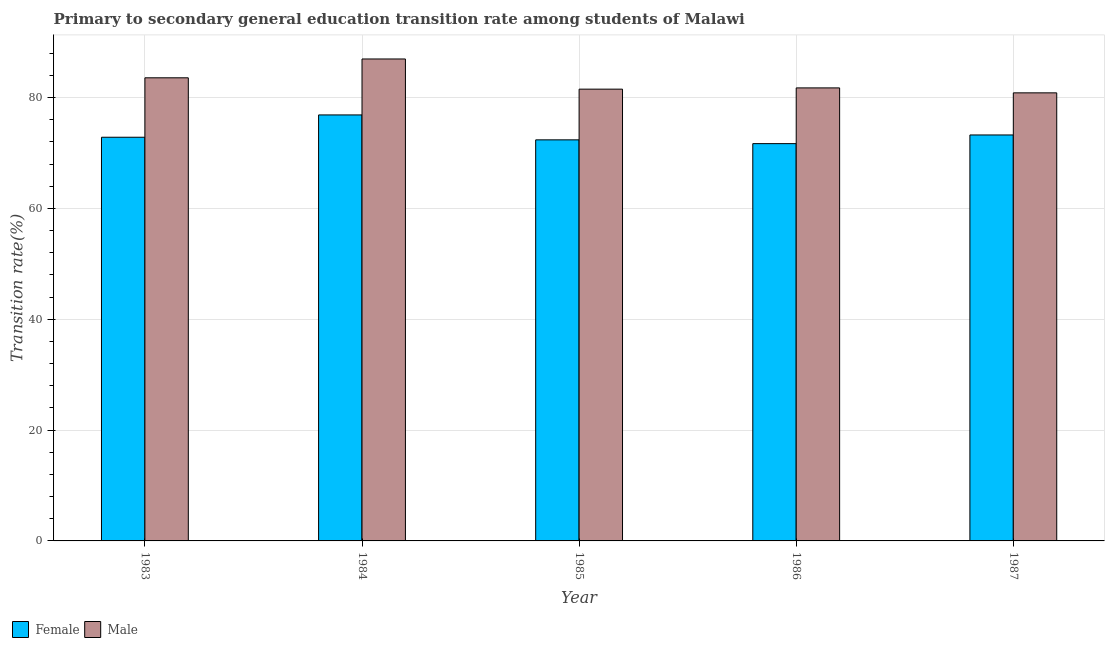How many groups of bars are there?
Offer a terse response. 5. How many bars are there on the 1st tick from the left?
Make the answer very short. 2. How many bars are there on the 1st tick from the right?
Your answer should be compact. 2. What is the transition rate among male students in 1986?
Ensure brevity in your answer.  81.76. Across all years, what is the maximum transition rate among female students?
Offer a terse response. 76.89. Across all years, what is the minimum transition rate among male students?
Provide a succinct answer. 80.87. In which year was the transition rate among male students maximum?
Your answer should be compact. 1984. In which year was the transition rate among female students minimum?
Keep it short and to the point. 1986. What is the total transition rate among male students in the graph?
Your answer should be compact. 414.74. What is the difference between the transition rate among male students in 1985 and that in 1987?
Your answer should be compact. 0.67. What is the difference between the transition rate among female students in 1986 and the transition rate among male students in 1983?
Provide a short and direct response. -1.15. What is the average transition rate among male students per year?
Offer a very short reply. 82.95. In the year 1986, what is the difference between the transition rate among male students and transition rate among female students?
Keep it short and to the point. 0. In how many years, is the transition rate among male students greater than 72 %?
Give a very brief answer. 5. What is the ratio of the transition rate among male students in 1985 to that in 1987?
Your answer should be very brief. 1.01. Is the difference between the transition rate among female students in 1986 and 1987 greater than the difference between the transition rate among male students in 1986 and 1987?
Your answer should be very brief. No. What is the difference between the highest and the second highest transition rate among female students?
Make the answer very short. 3.62. What is the difference between the highest and the lowest transition rate among male students?
Offer a terse response. 6.11. What does the 1st bar from the right in 1987 represents?
Offer a very short reply. Male. How many bars are there?
Provide a succinct answer. 10. Does the graph contain grids?
Ensure brevity in your answer.  Yes. Where does the legend appear in the graph?
Your answer should be compact. Bottom left. What is the title of the graph?
Your response must be concise. Primary to secondary general education transition rate among students of Malawi. Does "Crop" appear as one of the legend labels in the graph?
Keep it short and to the point. No. What is the label or title of the Y-axis?
Keep it short and to the point. Transition rate(%). What is the Transition rate(%) in Female in 1983?
Ensure brevity in your answer.  72.86. What is the Transition rate(%) in Male in 1983?
Your answer should be very brief. 83.59. What is the Transition rate(%) of Female in 1984?
Give a very brief answer. 76.89. What is the Transition rate(%) in Male in 1984?
Keep it short and to the point. 86.98. What is the Transition rate(%) in Female in 1985?
Your response must be concise. 72.39. What is the Transition rate(%) in Male in 1985?
Your answer should be compact. 81.54. What is the Transition rate(%) in Female in 1986?
Your answer should be compact. 71.7. What is the Transition rate(%) of Male in 1986?
Keep it short and to the point. 81.76. What is the Transition rate(%) of Female in 1987?
Make the answer very short. 73.27. What is the Transition rate(%) in Male in 1987?
Provide a short and direct response. 80.87. Across all years, what is the maximum Transition rate(%) in Female?
Offer a very short reply. 76.89. Across all years, what is the maximum Transition rate(%) in Male?
Offer a very short reply. 86.98. Across all years, what is the minimum Transition rate(%) of Female?
Your response must be concise. 71.7. Across all years, what is the minimum Transition rate(%) of Male?
Your answer should be very brief. 80.87. What is the total Transition rate(%) of Female in the graph?
Offer a terse response. 367.1. What is the total Transition rate(%) in Male in the graph?
Your answer should be compact. 414.74. What is the difference between the Transition rate(%) of Female in 1983 and that in 1984?
Give a very brief answer. -4.03. What is the difference between the Transition rate(%) of Male in 1983 and that in 1984?
Provide a succinct answer. -3.4. What is the difference between the Transition rate(%) in Female in 1983 and that in 1985?
Your answer should be very brief. 0.47. What is the difference between the Transition rate(%) in Male in 1983 and that in 1985?
Provide a succinct answer. 2.05. What is the difference between the Transition rate(%) of Female in 1983 and that in 1986?
Keep it short and to the point. 1.15. What is the difference between the Transition rate(%) in Male in 1983 and that in 1986?
Provide a succinct answer. 1.82. What is the difference between the Transition rate(%) in Female in 1983 and that in 1987?
Provide a short and direct response. -0.41. What is the difference between the Transition rate(%) of Male in 1983 and that in 1987?
Provide a short and direct response. 2.72. What is the difference between the Transition rate(%) in Female in 1984 and that in 1985?
Offer a terse response. 4.5. What is the difference between the Transition rate(%) of Male in 1984 and that in 1985?
Your response must be concise. 5.45. What is the difference between the Transition rate(%) in Female in 1984 and that in 1986?
Provide a short and direct response. 5.18. What is the difference between the Transition rate(%) of Male in 1984 and that in 1986?
Your answer should be compact. 5.22. What is the difference between the Transition rate(%) of Female in 1984 and that in 1987?
Provide a succinct answer. 3.62. What is the difference between the Transition rate(%) of Male in 1984 and that in 1987?
Make the answer very short. 6.11. What is the difference between the Transition rate(%) in Female in 1985 and that in 1986?
Your response must be concise. 0.69. What is the difference between the Transition rate(%) of Male in 1985 and that in 1986?
Provide a short and direct response. -0.23. What is the difference between the Transition rate(%) in Female in 1985 and that in 1987?
Offer a very short reply. -0.88. What is the difference between the Transition rate(%) in Male in 1985 and that in 1987?
Keep it short and to the point. 0.67. What is the difference between the Transition rate(%) in Female in 1986 and that in 1987?
Ensure brevity in your answer.  -1.57. What is the difference between the Transition rate(%) in Male in 1986 and that in 1987?
Your answer should be very brief. 0.89. What is the difference between the Transition rate(%) of Female in 1983 and the Transition rate(%) of Male in 1984?
Ensure brevity in your answer.  -14.13. What is the difference between the Transition rate(%) in Female in 1983 and the Transition rate(%) in Male in 1985?
Your answer should be very brief. -8.68. What is the difference between the Transition rate(%) in Female in 1983 and the Transition rate(%) in Male in 1986?
Ensure brevity in your answer.  -8.91. What is the difference between the Transition rate(%) of Female in 1983 and the Transition rate(%) of Male in 1987?
Give a very brief answer. -8.01. What is the difference between the Transition rate(%) in Female in 1984 and the Transition rate(%) in Male in 1985?
Keep it short and to the point. -4.65. What is the difference between the Transition rate(%) of Female in 1984 and the Transition rate(%) of Male in 1986?
Your response must be concise. -4.88. What is the difference between the Transition rate(%) in Female in 1984 and the Transition rate(%) in Male in 1987?
Your response must be concise. -3.98. What is the difference between the Transition rate(%) in Female in 1985 and the Transition rate(%) in Male in 1986?
Give a very brief answer. -9.38. What is the difference between the Transition rate(%) in Female in 1985 and the Transition rate(%) in Male in 1987?
Give a very brief answer. -8.48. What is the difference between the Transition rate(%) in Female in 1986 and the Transition rate(%) in Male in 1987?
Provide a succinct answer. -9.17. What is the average Transition rate(%) of Female per year?
Your answer should be very brief. 73.42. What is the average Transition rate(%) in Male per year?
Provide a succinct answer. 82.95. In the year 1983, what is the difference between the Transition rate(%) of Female and Transition rate(%) of Male?
Give a very brief answer. -10.73. In the year 1984, what is the difference between the Transition rate(%) in Female and Transition rate(%) in Male?
Offer a terse response. -10.1. In the year 1985, what is the difference between the Transition rate(%) in Female and Transition rate(%) in Male?
Provide a succinct answer. -9.15. In the year 1986, what is the difference between the Transition rate(%) in Female and Transition rate(%) in Male?
Your answer should be very brief. -10.06. In the year 1987, what is the difference between the Transition rate(%) of Female and Transition rate(%) of Male?
Your answer should be very brief. -7.6. What is the ratio of the Transition rate(%) in Female in 1983 to that in 1984?
Your response must be concise. 0.95. What is the ratio of the Transition rate(%) in Male in 1983 to that in 1984?
Make the answer very short. 0.96. What is the ratio of the Transition rate(%) in Female in 1983 to that in 1985?
Give a very brief answer. 1.01. What is the ratio of the Transition rate(%) in Male in 1983 to that in 1985?
Offer a terse response. 1.03. What is the ratio of the Transition rate(%) in Female in 1983 to that in 1986?
Your response must be concise. 1.02. What is the ratio of the Transition rate(%) of Male in 1983 to that in 1986?
Your answer should be very brief. 1.02. What is the ratio of the Transition rate(%) of Female in 1983 to that in 1987?
Provide a short and direct response. 0.99. What is the ratio of the Transition rate(%) in Male in 1983 to that in 1987?
Provide a succinct answer. 1.03. What is the ratio of the Transition rate(%) of Female in 1984 to that in 1985?
Make the answer very short. 1.06. What is the ratio of the Transition rate(%) of Male in 1984 to that in 1985?
Offer a very short reply. 1.07. What is the ratio of the Transition rate(%) of Female in 1984 to that in 1986?
Your response must be concise. 1.07. What is the ratio of the Transition rate(%) in Male in 1984 to that in 1986?
Your answer should be very brief. 1.06. What is the ratio of the Transition rate(%) in Female in 1984 to that in 1987?
Keep it short and to the point. 1.05. What is the ratio of the Transition rate(%) in Male in 1984 to that in 1987?
Your answer should be compact. 1.08. What is the ratio of the Transition rate(%) of Female in 1985 to that in 1986?
Provide a succinct answer. 1.01. What is the ratio of the Transition rate(%) in Male in 1985 to that in 1986?
Offer a very short reply. 1. What is the ratio of the Transition rate(%) of Female in 1985 to that in 1987?
Your response must be concise. 0.99. What is the ratio of the Transition rate(%) in Male in 1985 to that in 1987?
Make the answer very short. 1.01. What is the ratio of the Transition rate(%) in Female in 1986 to that in 1987?
Your response must be concise. 0.98. What is the ratio of the Transition rate(%) in Male in 1986 to that in 1987?
Make the answer very short. 1.01. What is the difference between the highest and the second highest Transition rate(%) of Female?
Give a very brief answer. 3.62. What is the difference between the highest and the second highest Transition rate(%) of Male?
Ensure brevity in your answer.  3.4. What is the difference between the highest and the lowest Transition rate(%) in Female?
Offer a very short reply. 5.18. What is the difference between the highest and the lowest Transition rate(%) of Male?
Provide a short and direct response. 6.11. 